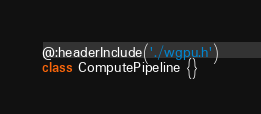<code> <loc_0><loc_0><loc_500><loc_500><_Haxe_>@:headerInclude('./wgpu.h')
class ComputePipeline {}
</code> 